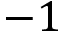<formula> <loc_0><loc_0><loc_500><loc_500>- 1</formula> 